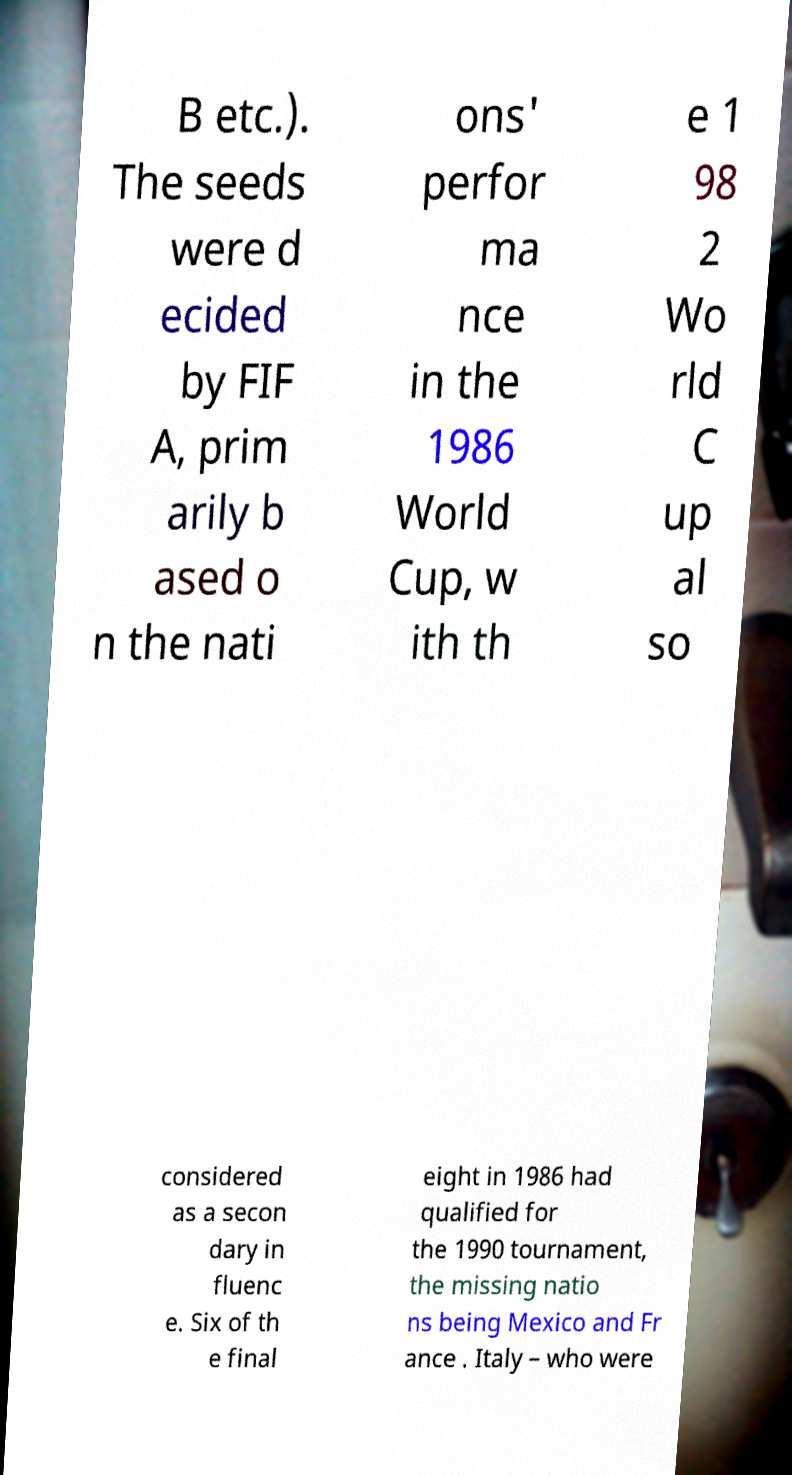What messages or text are displayed in this image? I need them in a readable, typed format. B etc.). The seeds were d ecided by FIF A, prim arily b ased o n the nati ons' perfor ma nce in the 1986 World Cup, w ith th e 1 98 2 Wo rld C up al so considered as a secon dary in fluenc e. Six of th e final eight in 1986 had qualified for the 1990 tournament, the missing natio ns being Mexico and Fr ance . Italy – who were 